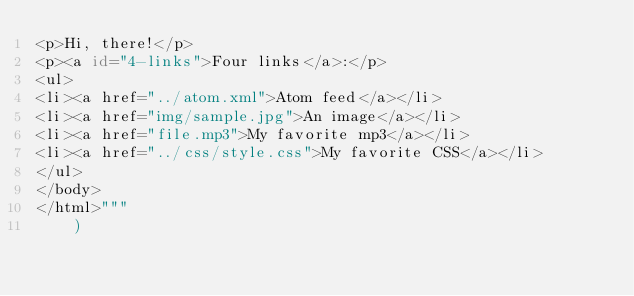Convert code to text. <code><loc_0><loc_0><loc_500><loc_500><_Python_><p>Hi, there!</p>
<p><a id="4-links">Four links</a>:</p>
<ul>
<li><a href="../atom.xml">Atom feed</a></li>
<li><a href="img/sample.jpg">An image</a></li>
<li><a href="file.mp3">My favorite mp3</a></li>
<li><a href="../css/style.css">My favorite CSS</a></li>
</ul>
</body>
</html>"""
    )

</code> 